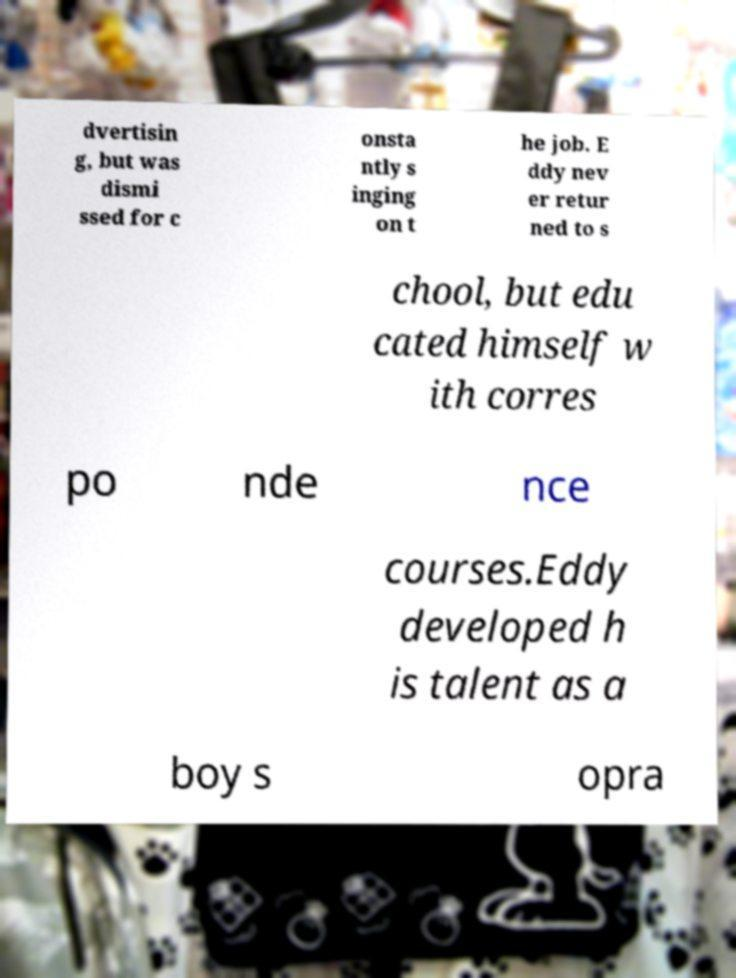Can you read and provide the text displayed in the image?This photo seems to have some interesting text. Can you extract and type it out for me? dvertisin g, but was dismi ssed for c onsta ntly s inging on t he job. E ddy nev er retur ned to s chool, but edu cated himself w ith corres po nde nce courses.Eddy developed h is talent as a boy s opra 